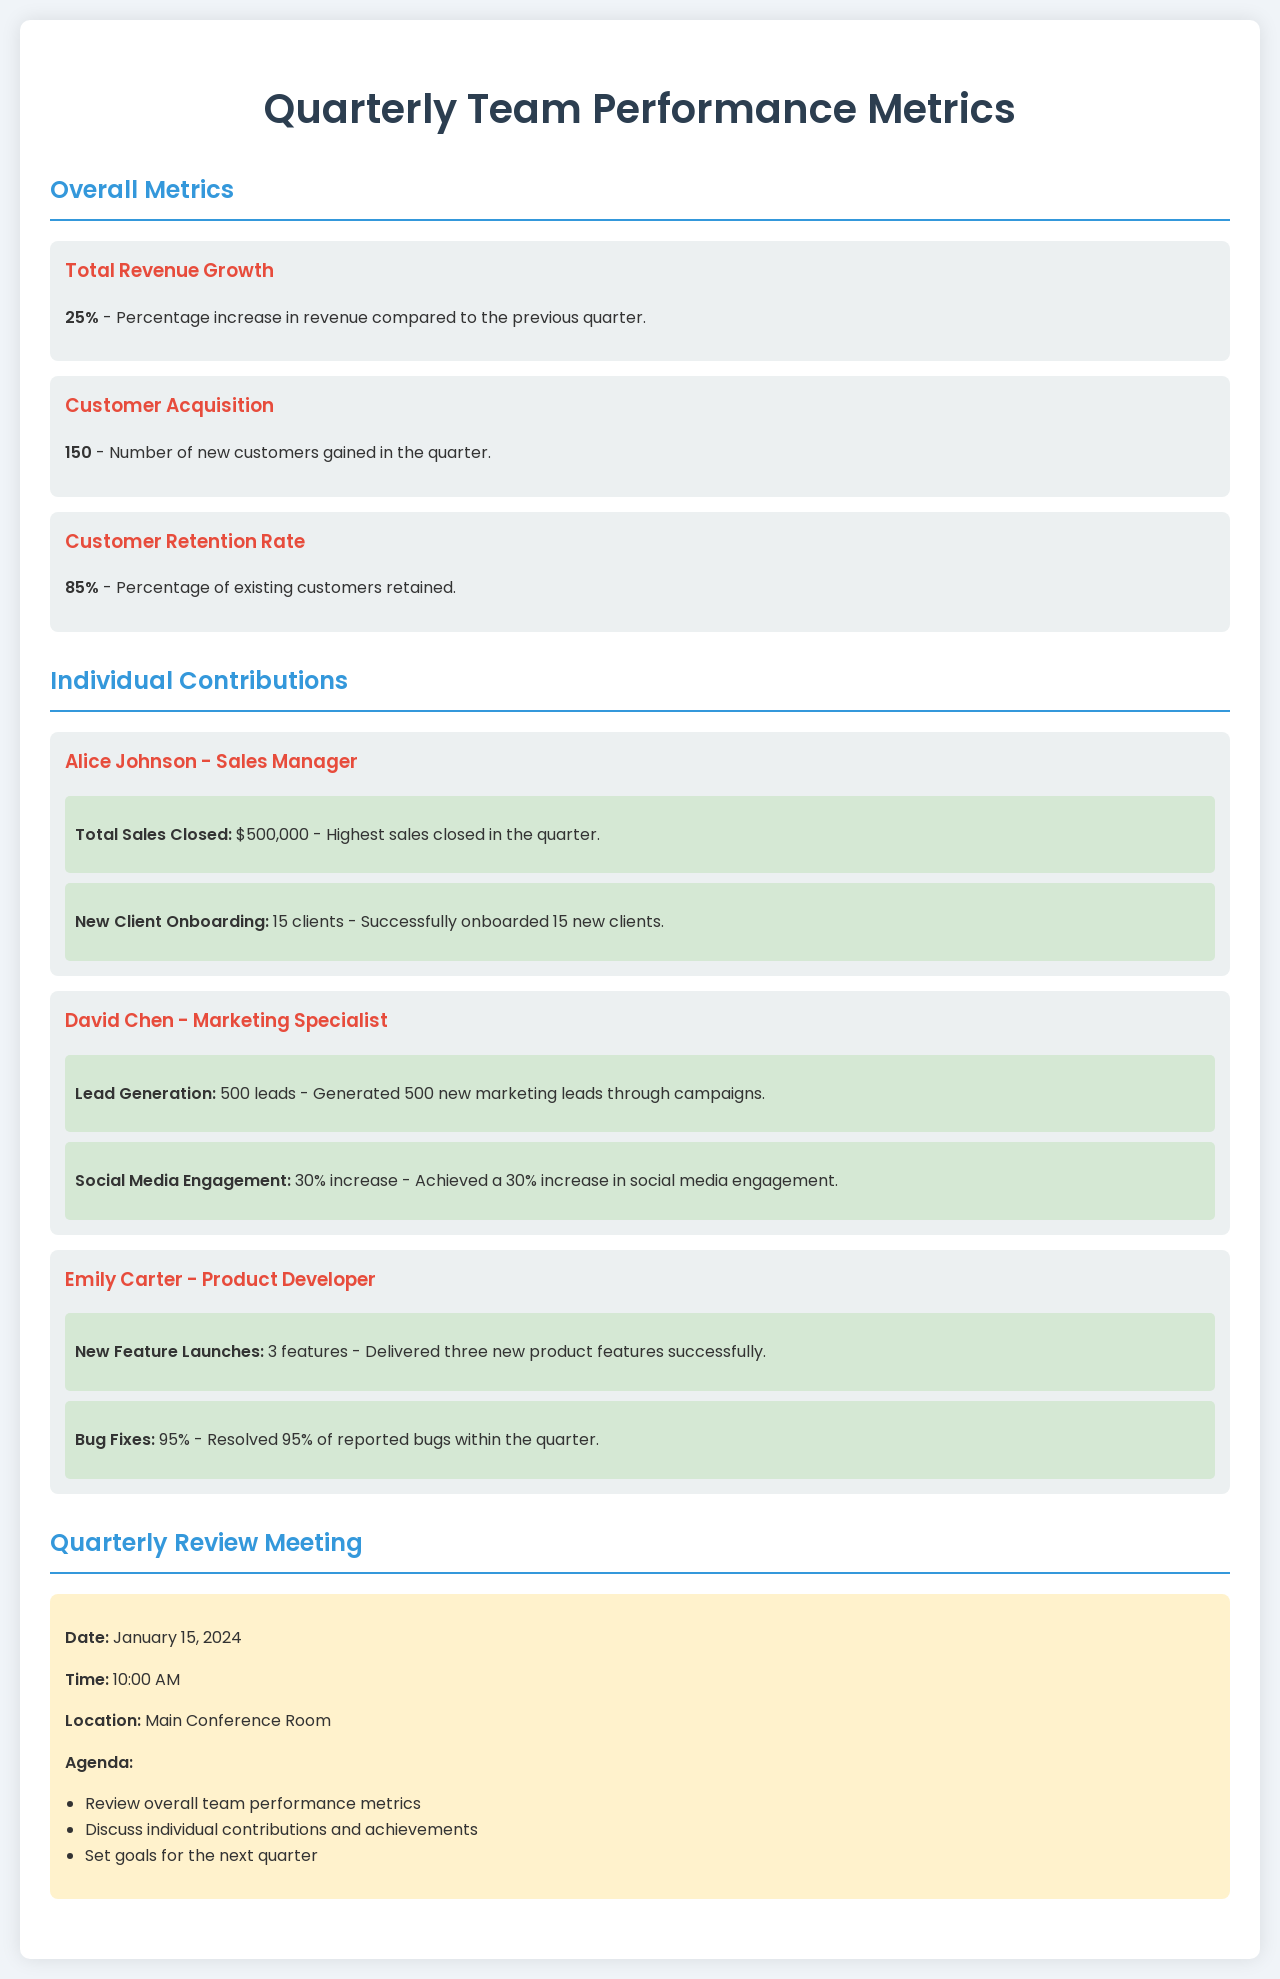What is the percentage increase in total revenue? The document states that the total revenue growth is a percentage increase of 25% compared to the previous quarter.
Answer: 25% How many new customers were gained in the quarter? According to the document, the number of new customers gained in the quarter is 150.
Answer: 150 Who closed the highest sales in the quarter? The document indicates that Alice Johnson, the Sales Manager, closed the highest sales of $500,000.
Answer: Alice Johnson What percentage of reported bugs were resolved by Emily Carter? It is mentioned that Emily Carter resolved 95% of reported bugs within the quarter.
Answer: 95% What is the date of the Quarterly Review Meeting? The document specifies that the Quarterly Review Meeting is scheduled for January 15, 2024.
Answer: January 15, 2024 How many new product features were delivered by Emily Carter? The document states that Emily Carter delivered three new product features successfully.
Answer: 3 What was David Chen's increase in social media engagement? The document shows that David Chen achieved a 30% increase in social media engagement.
Answer: 30% What is the time of the Quarterly Review Meeting? According to the document, the meeting is set for 10:00 AM.
Answer: 10:00 AM 